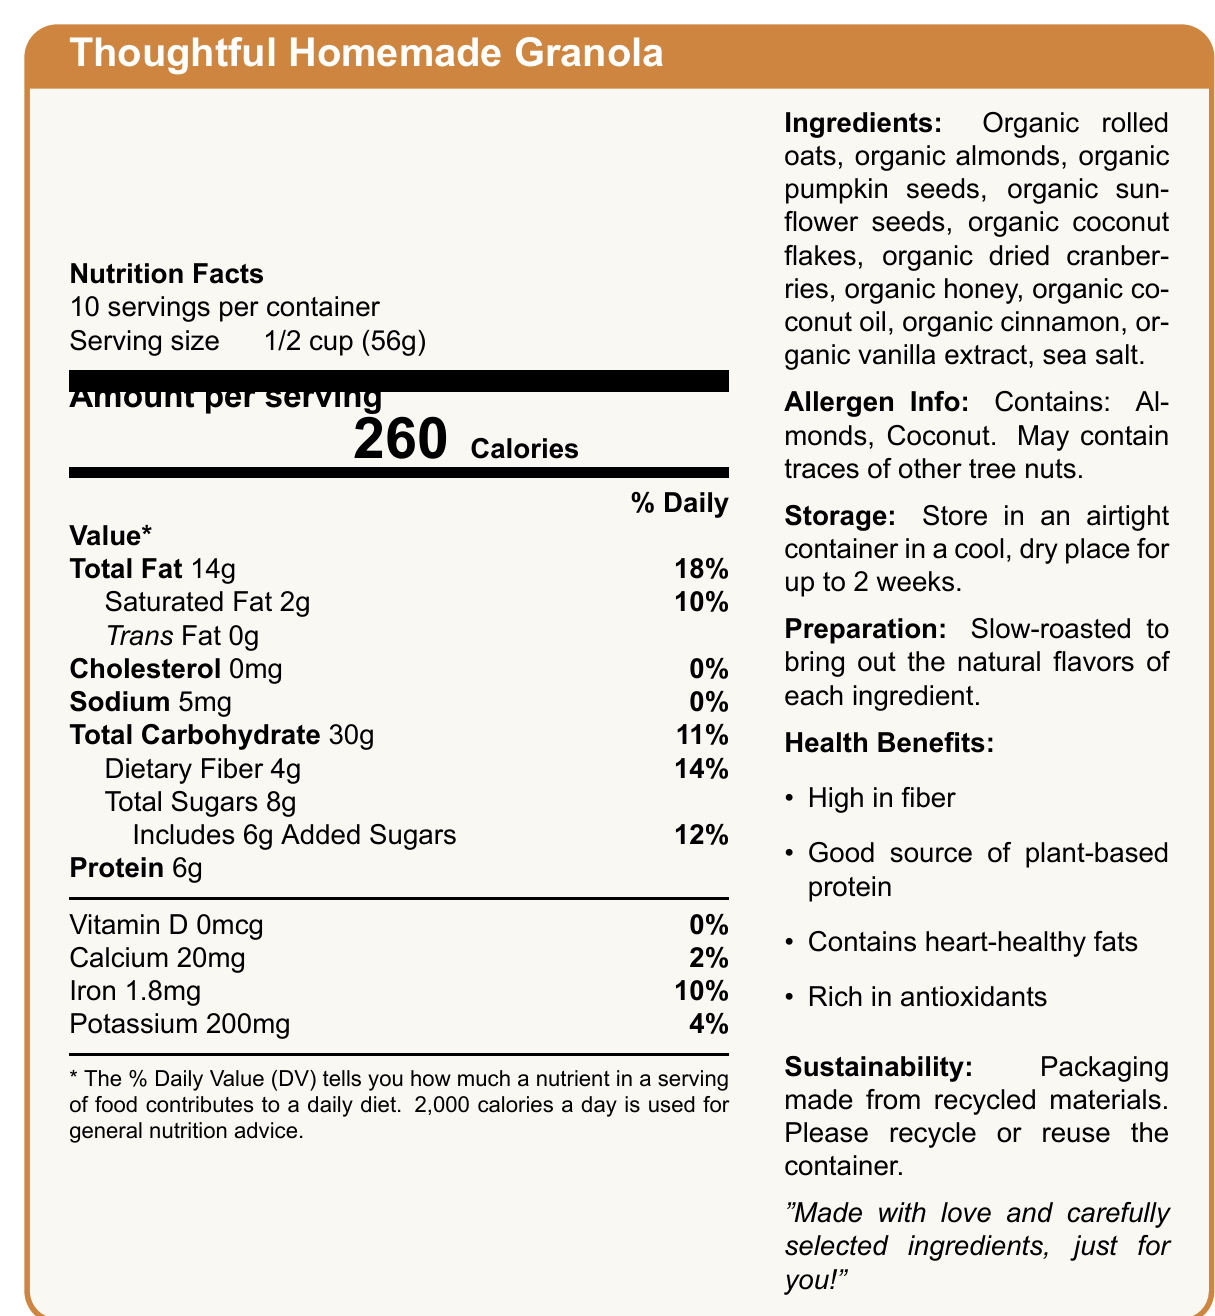what is the serving size? The serving size is explicitly listed as "1/2 cup (56g)" in the Nutrition Facts section.
Answer: 1/2 cup (56g) how many servings are in the container? The document states that there are 10 servings per container.
Answer: 10 how many calories are in one serving of the granola? The document lists 260 calories per serving next to the "Calories" label in large text.
Answer: 260 what is the total amount of fat per serving? Under the Nutrition Facts, it shows "Total Fat 14g".
Answer: 14g what percent of the daily value is the dietary fiber? The document states that the dietary fiber is 4g, which is 14% of the daily value.
Answer: 14% how much iron does one serving of granola provide? The amount of iron per serving is shown as 1.8mg in the Micronutrient values section.
Answer: 1.8 mg which of the following ingredients is not listed in the granola? A. Organic Honey B. Organic Almonds C. Organic Raisins D. Sea Salt The ingredients list includes organic honey, organic almonds, and sea salt, but there is no mention of organic raisins.
Answer: C how much of the total sugars are added sugars? A. 2g B. 4g C. 6g D. 8g The document specifies that the total sugars are 8g, with 6g of them being added sugars.
Answer: C does the granola contain any cholesterol? The document shows "Cholesterol 0mg", indicating that the granola does not contain any cholesterol.
Answer: No is this granola mixture a good source of vitamin D? The document lists Vitamin D as 0mcg which is 0% of the daily value, indicating it is not a source of Vitamin D.
Answer: No Which of the following minerals is present in the highest amount per serving? i. Calcium ii. Iron iii. Potassium The amounts per serving are: Calcium - 20mg, Iron - 1.8mg, Potassium - 200mg. Potassium is present in the highest amount.
Answer: iii. Potassium what are the health benefits mentioned for the granola? These health benefits are listed under the Health Benefits section on the right side of the document.
Answer: High in fiber, Good source of plant-based protein, Contains heart-healthy fats, Rich in antioxidants how should the granola be stored? The storage instructions are given in the document's right column.
Answer: Store in an airtight container in a cool, dry place for up to 2 weeks. what does the document say about sustainability? The sustainability note is under the Sustainability section on the right side.
Answer: Packaging made from recycled materials. Please recycle or reuse the container. what is the main idea of the document? This summary encapsulates the details provided about the granola, focusing on its thoughtful preparation and nutrition.
Answer: The document provides comprehensive nutritional information, ingredients, health benefits, and storage instructions for a customized homemade granola gift made with thoughtful, organic ingredients. what preparation method is used for the granola? The preparation method is mentioned in the right column of the document.
Answer: Slow-roasted to bring out the natural flavors of each ingredient. what daily value percentage of the granola is based on a 2,000-calorie diet? The document does not provide the individual daily caloric intake used to compute the daily value percentages.
Answer: Cannot be determined 